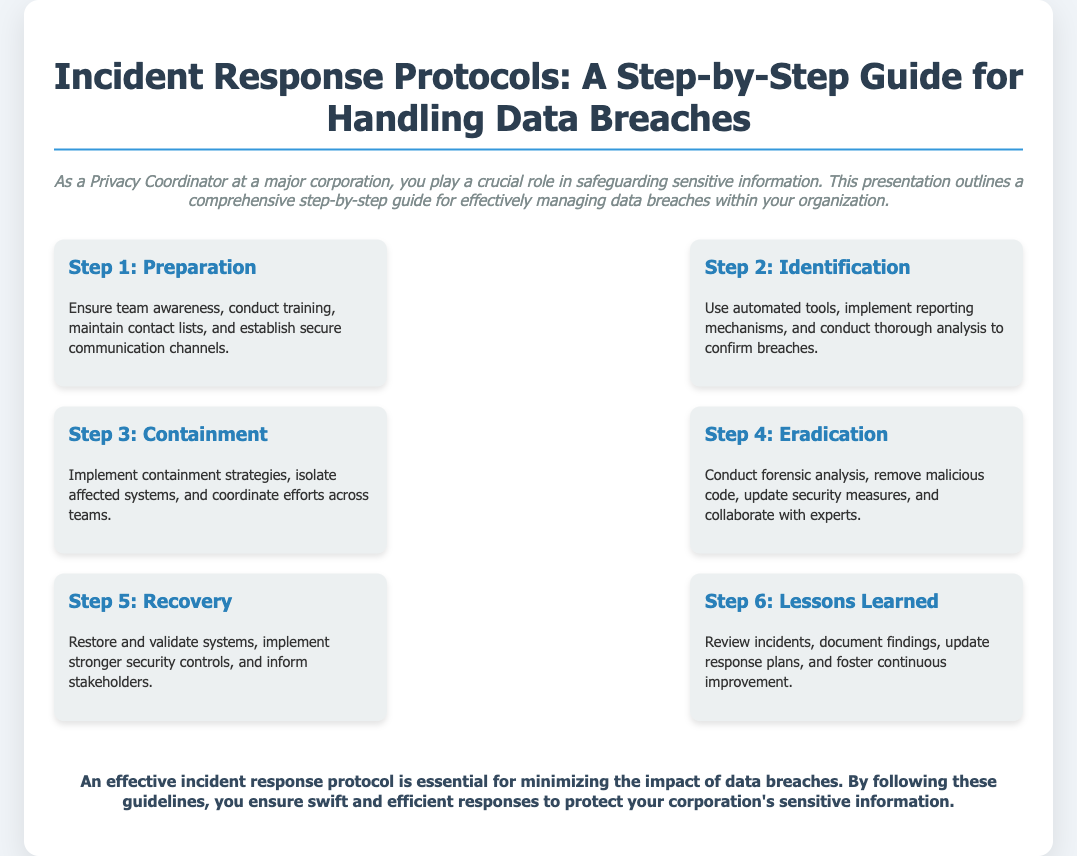What is the main title of the presentation? The title is prominently displayed at the top of the document, summarizing the presentation's focus on managing data breaches.
Answer: Incident Response Protocols: A Step-by-Step Guide for Handling Data Breaches How many steps are outlined in the guide? The document provides a clear list of steps in managing data breaches, and counting those yields the total number.
Answer: Six What is the content of Step 3? The document specifies the focus of each step; Step 3 includes specific actions for dealing with breaches.
Answer: Containment What is mentioned in Step 6 regarding improvements? The conclusion of Step 6 highlights the importance of reviewing and updating plans to enhance response effectiveness.
Answer: Continuous improvement Which step focuses on removing malicious code? Each step is assigned tasks related to the incident response, with one step specifically dedicated to the removal of threats.
Answer: Step 4 What is emphasized in the conclusion? The conclusion summarizes the importance of the protocols in protecting sensitive information within a corporation.
Answer: Minimize the impact of data breaches 